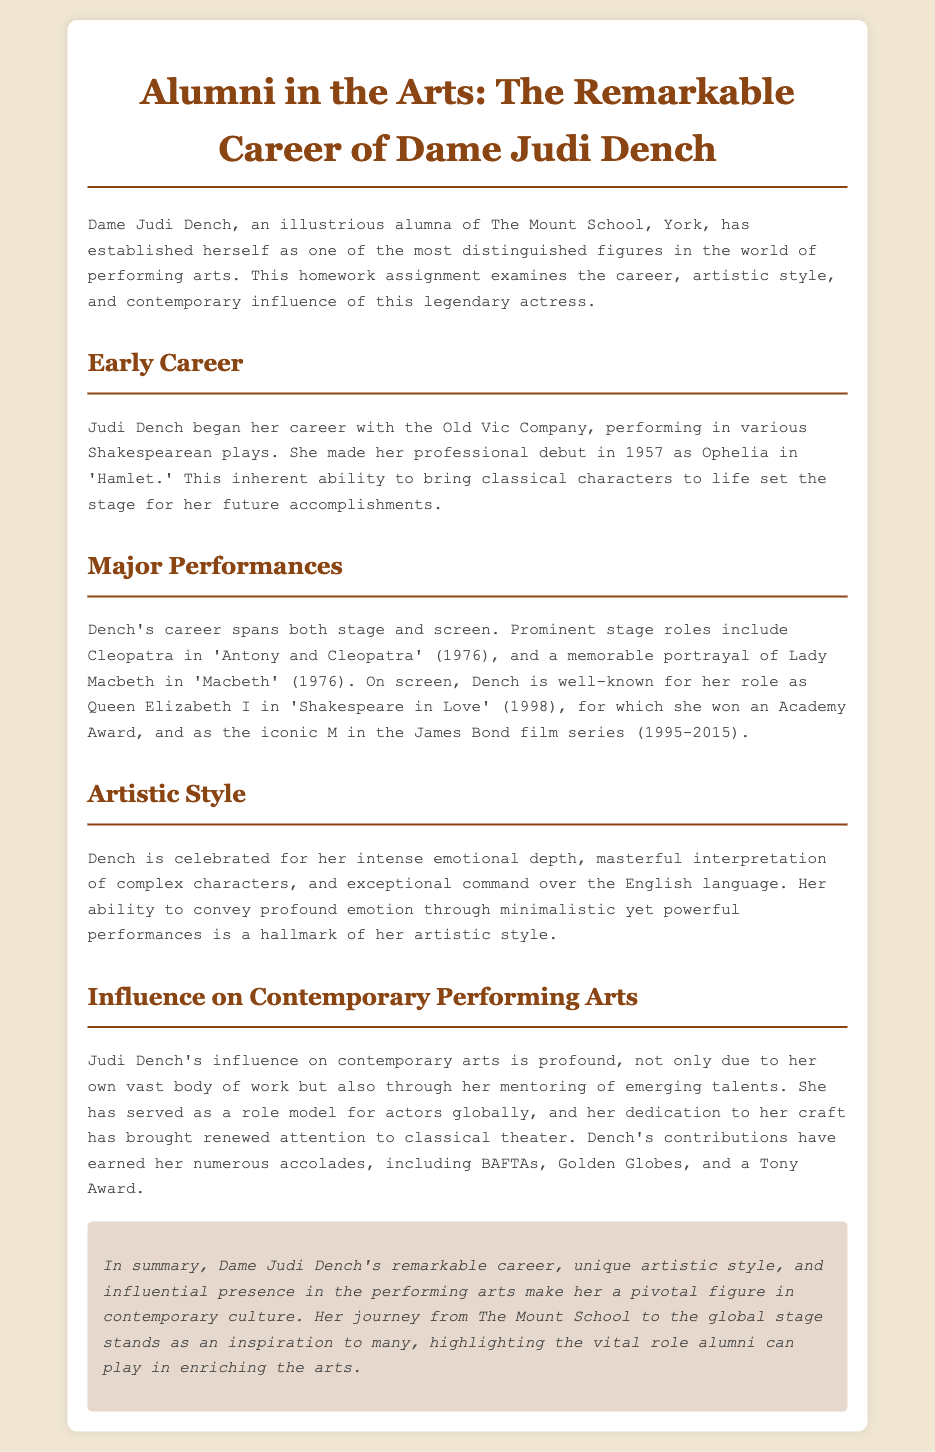What year did Judi Dench make her professional debut? The document states that Judi Dench made her professional debut in 1957 as Ophelia in 'Hamlet.'
Answer: 1957 What role did Dench play in 'Antony and Cleopatra'? The document mentions her prominent stage role as Cleopatra in 'Antony and Cleopatra' in 1976.
Answer: Cleopatra What iconic character did Judi Dench portray in the James Bond film series? According to the document, Dench is well-known for her role as M in the James Bond film series.
Answer: M What award did Dench win for her role in 'Shakespeare in Love'? The document indicates that she won an Academy Award for her role as Queen Elizabeth I in 'Shakespeare in Love.'
Answer: Academy Award What is a hallmark of Judi Dench's artistic style? The document describes her ability to convey profound emotion through minimalistic yet powerful performances as a hallmark of her artistic style.
Answer: Minimalistic yet powerful performances How has Judi Dench influenced emerging talents? The document states that she has served as a role model for actors globally, indicating her influence on emerging talents.
Answer: Role model How many Tony Awards has Judi Dench won? The document does not specify the number of Tony Awards won but mentions that she has received various accolades including a Tony Award.
Answer: Not specified What school did Judi Dench attend? The document states that she is an alumna of The Mount School, York.
Answer: The Mount School, York What year span does Dench's role as M in the James Bond series cover? The document states that her role as M spanned from 1995 to 2015.
Answer: 1995-2015 